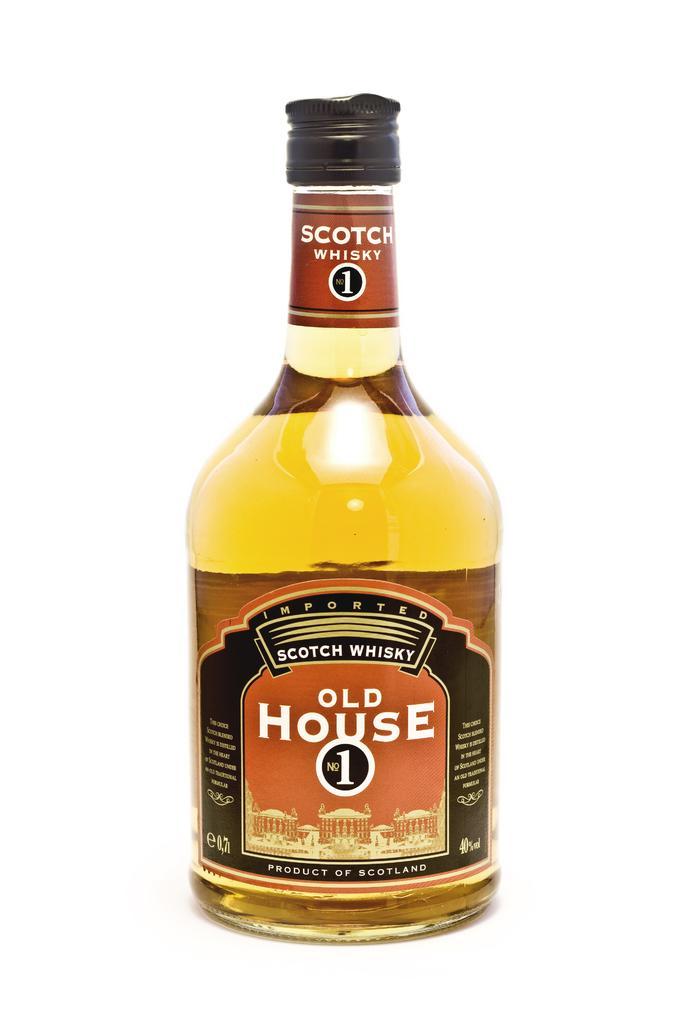Please provide a concise description of this image. here we can see a wine bottle as whisky, and a label on it. 